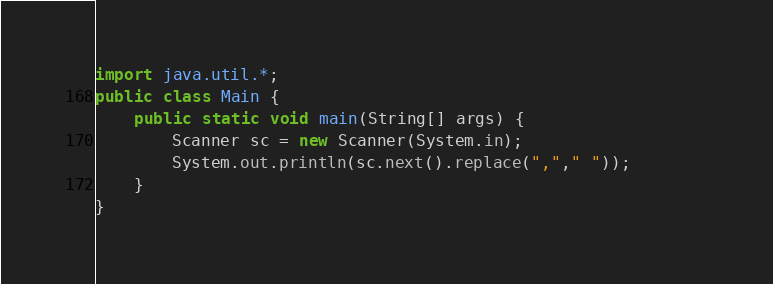Convert code to text. <code><loc_0><loc_0><loc_500><loc_500><_Java_>import java.util.*;
public class Main {
	public static void main(String[] args) {
		Scanner sc = new Scanner(System.in);
		System.out.println(sc.next().replace(","," "));		
	}
}</code> 